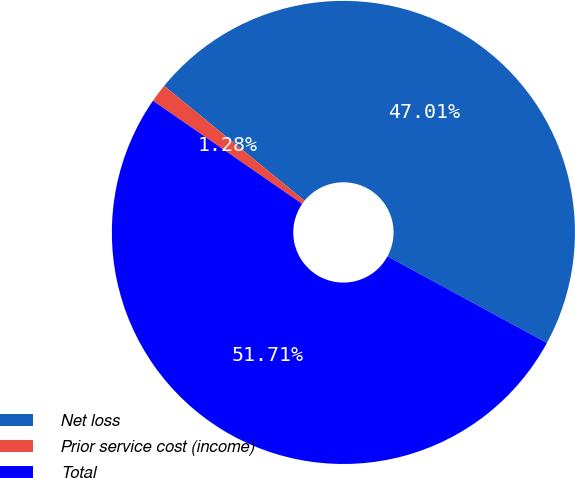<chart> <loc_0><loc_0><loc_500><loc_500><pie_chart><fcel>Net loss<fcel>Prior service cost (income)<fcel>Total<nl><fcel>47.01%<fcel>1.28%<fcel>51.71%<nl></chart> 